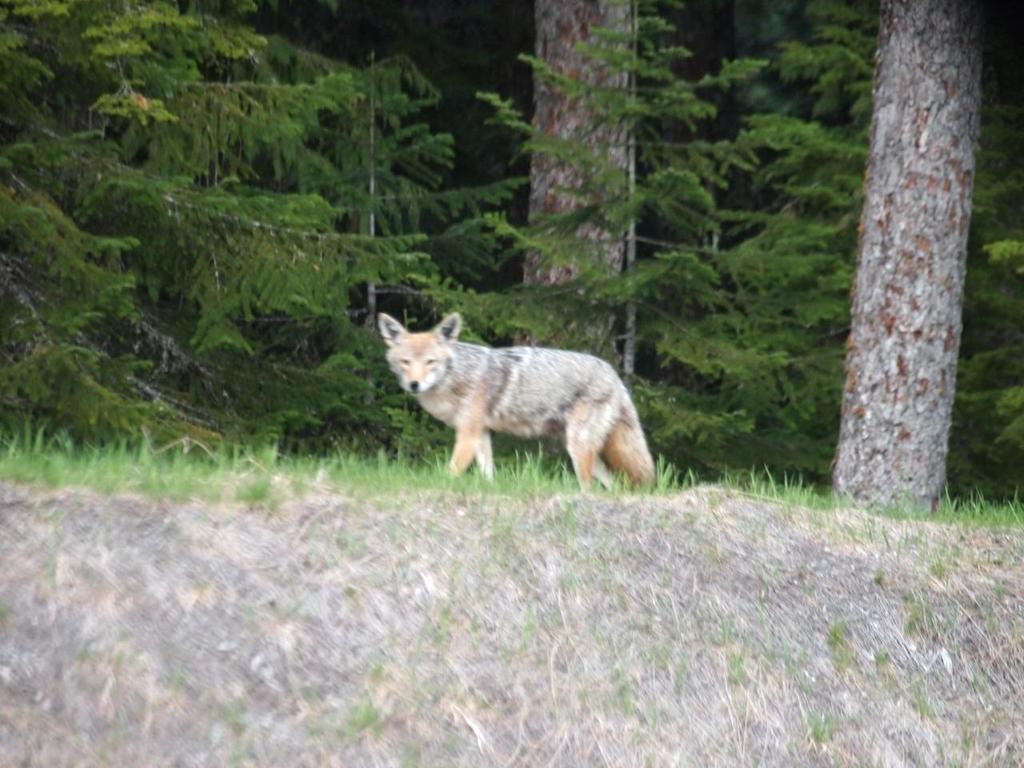Describe this image in one or two sentences. This image consists of a wolf walking on the ground. At the bottom, we can see green grass. In the background, there are many trees. It looks like it is clicked in a forest. 